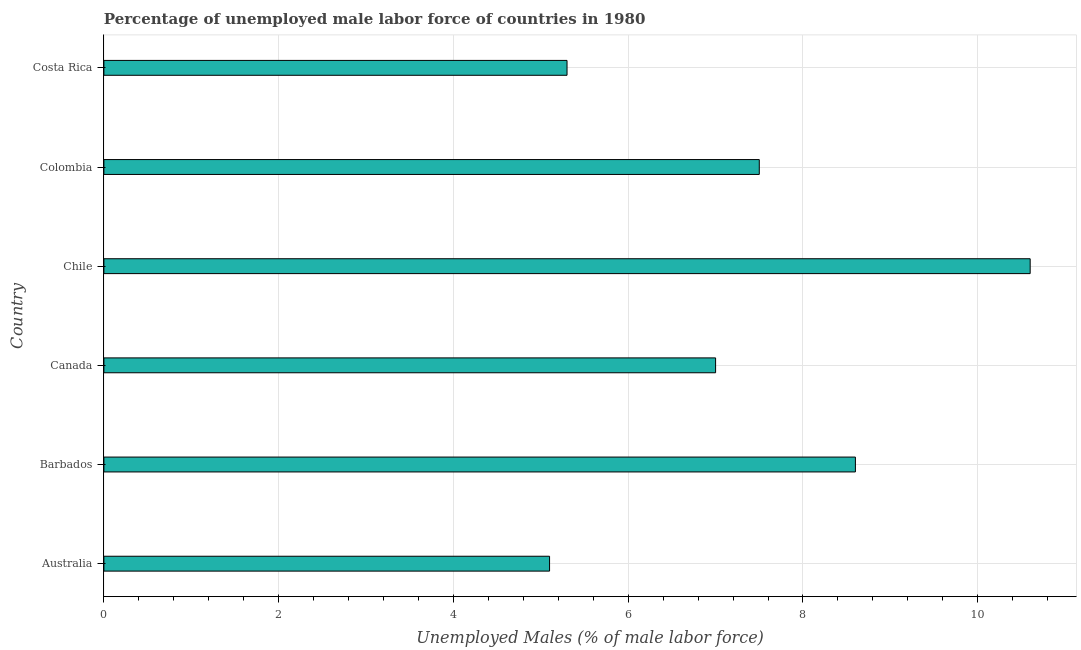What is the title of the graph?
Provide a succinct answer. Percentage of unemployed male labor force of countries in 1980. What is the label or title of the X-axis?
Your response must be concise. Unemployed Males (% of male labor force). What is the total unemployed male labour force in Costa Rica?
Make the answer very short. 5.3. Across all countries, what is the maximum total unemployed male labour force?
Provide a succinct answer. 10.6. Across all countries, what is the minimum total unemployed male labour force?
Your answer should be compact. 5.1. What is the sum of the total unemployed male labour force?
Keep it short and to the point. 44.1. What is the difference between the total unemployed male labour force in Colombia and Costa Rica?
Your answer should be very brief. 2.2. What is the average total unemployed male labour force per country?
Provide a short and direct response. 7.35. What is the median total unemployed male labour force?
Ensure brevity in your answer.  7.25. In how many countries, is the total unemployed male labour force greater than 2.8 %?
Provide a short and direct response. 6. What is the ratio of the total unemployed male labour force in Barbados to that in Canada?
Offer a very short reply. 1.23. Is the total unemployed male labour force in Chile less than that in Colombia?
Your answer should be compact. No. Is the difference between the total unemployed male labour force in Canada and Colombia greater than the difference between any two countries?
Give a very brief answer. No. What is the difference between the highest and the second highest total unemployed male labour force?
Give a very brief answer. 2. What is the difference between the highest and the lowest total unemployed male labour force?
Offer a very short reply. 5.5. Are all the bars in the graph horizontal?
Your answer should be very brief. Yes. How many countries are there in the graph?
Keep it short and to the point. 6. What is the Unemployed Males (% of male labor force) of Australia?
Keep it short and to the point. 5.1. What is the Unemployed Males (% of male labor force) of Barbados?
Ensure brevity in your answer.  8.6. What is the Unemployed Males (% of male labor force) of Canada?
Offer a very short reply. 7. What is the Unemployed Males (% of male labor force) in Chile?
Provide a succinct answer. 10.6. What is the Unemployed Males (% of male labor force) of Colombia?
Your response must be concise. 7.5. What is the Unemployed Males (% of male labor force) of Costa Rica?
Offer a very short reply. 5.3. What is the difference between the Unemployed Males (% of male labor force) in Australia and Canada?
Keep it short and to the point. -1.9. What is the difference between the Unemployed Males (% of male labor force) in Australia and Colombia?
Give a very brief answer. -2.4. What is the difference between the Unemployed Males (% of male labor force) in Barbados and Chile?
Offer a very short reply. -2. What is the difference between the Unemployed Males (% of male labor force) in Barbados and Costa Rica?
Provide a succinct answer. 3.3. What is the difference between the Unemployed Males (% of male labor force) in Canada and Costa Rica?
Provide a succinct answer. 1.7. What is the difference between the Unemployed Males (% of male labor force) in Chile and Costa Rica?
Provide a short and direct response. 5.3. What is the ratio of the Unemployed Males (% of male labor force) in Australia to that in Barbados?
Your response must be concise. 0.59. What is the ratio of the Unemployed Males (% of male labor force) in Australia to that in Canada?
Your answer should be very brief. 0.73. What is the ratio of the Unemployed Males (% of male labor force) in Australia to that in Chile?
Offer a very short reply. 0.48. What is the ratio of the Unemployed Males (% of male labor force) in Australia to that in Colombia?
Your answer should be very brief. 0.68. What is the ratio of the Unemployed Males (% of male labor force) in Australia to that in Costa Rica?
Provide a succinct answer. 0.96. What is the ratio of the Unemployed Males (% of male labor force) in Barbados to that in Canada?
Give a very brief answer. 1.23. What is the ratio of the Unemployed Males (% of male labor force) in Barbados to that in Chile?
Offer a very short reply. 0.81. What is the ratio of the Unemployed Males (% of male labor force) in Barbados to that in Colombia?
Provide a short and direct response. 1.15. What is the ratio of the Unemployed Males (% of male labor force) in Barbados to that in Costa Rica?
Your answer should be very brief. 1.62. What is the ratio of the Unemployed Males (% of male labor force) in Canada to that in Chile?
Your answer should be very brief. 0.66. What is the ratio of the Unemployed Males (% of male labor force) in Canada to that in Colombia?
Offer a terse response. 0.93. What is the ratio of the Unemployed Males (% of male labor force) in Canada to that in Costa Rica?
Provide a succinct answer. 1.32. What is the ratio of the Unemployed Males (% of male labor force) in Chile to that in Colombia?
Offer a very short reply. 1.41. What is the ratio of the Unemployed Males (% of male labor force) in Chile to that in Costa Rica?
Your response must be concise. 2. What is the ratio of the Unemployed Males (% of male labor force) in Colombia to that in Costa Rica?
Keep it short and to the point. 1.42. 